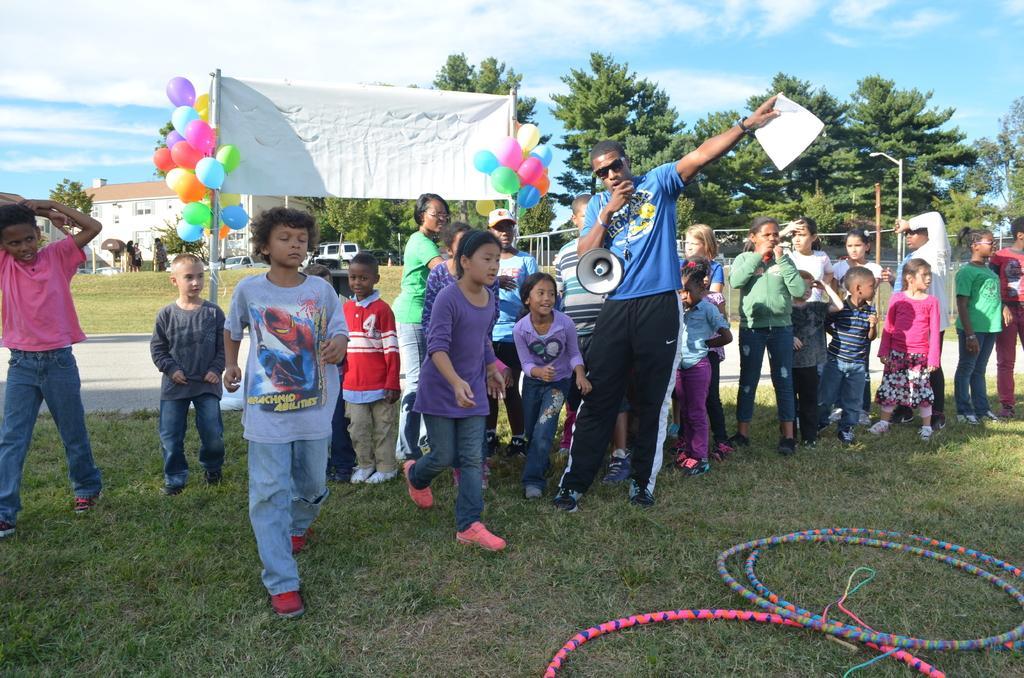In one or two sentences, can you explain what this image depicts? This is an outside view and it is looking like a garden. Here I can see few children are standing and few are running. There is a man standing, holding a mike in the hand and speaking something. At the bottom of the image I can see the rings on the ground. In the background there is a building, few cars and also I can see some trees. On the top of the image I can see the sky and clouds. At the back of these children there is a banner which is in white color and I can see few balloons to that. 